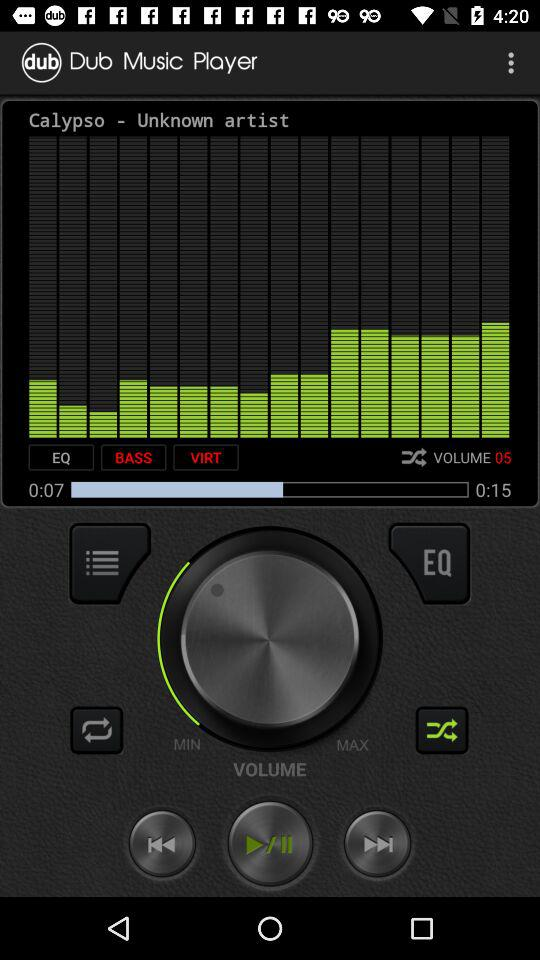What is the application name? The application name is "Dub Music Player". 